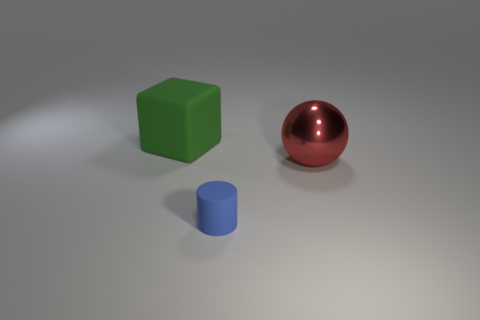Add 2 small blue rubber objects. How many objects exist? 5 Subtract all cubes. How many objects are left? 2 Subtract all shiny balls. Subtract all large green cylinders. How many objects are left? 2 Add 3 red spheres. How many red spheres are left? 4 Add 3 large brown balls. How many large brown balls exist? 3 Subtract 0 purple blocks. How many objects are left? 3 